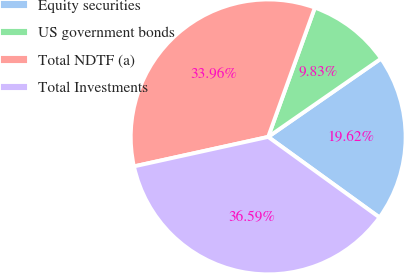Convert chart. <chart><loc_0><loc_0><loc_500><loc_500><pie_chart><fcel>Equity securities<fcel>US government bonds<fcel>Total NDTF (a)<fcel>Total Investments<nl><fcel>19.62%<fcel>9.83%<fcel>33.96%<fcel>36.59%<nl></chart> 